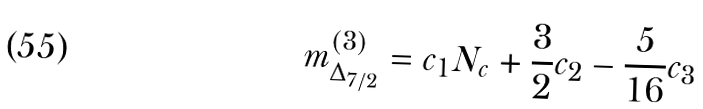Convert formula to latex. <formula><loc_0><loc_0><loc_500><loc_500>m ^ { ( 3 ) } _ { \Delta _ { 7 / 2 } } = c _ { 1 } N _ { c } + \frac { 3 } { 2 } c _ { 2 } - \frac { 5 } { 1 6 } c _ { 3 }</formula> 